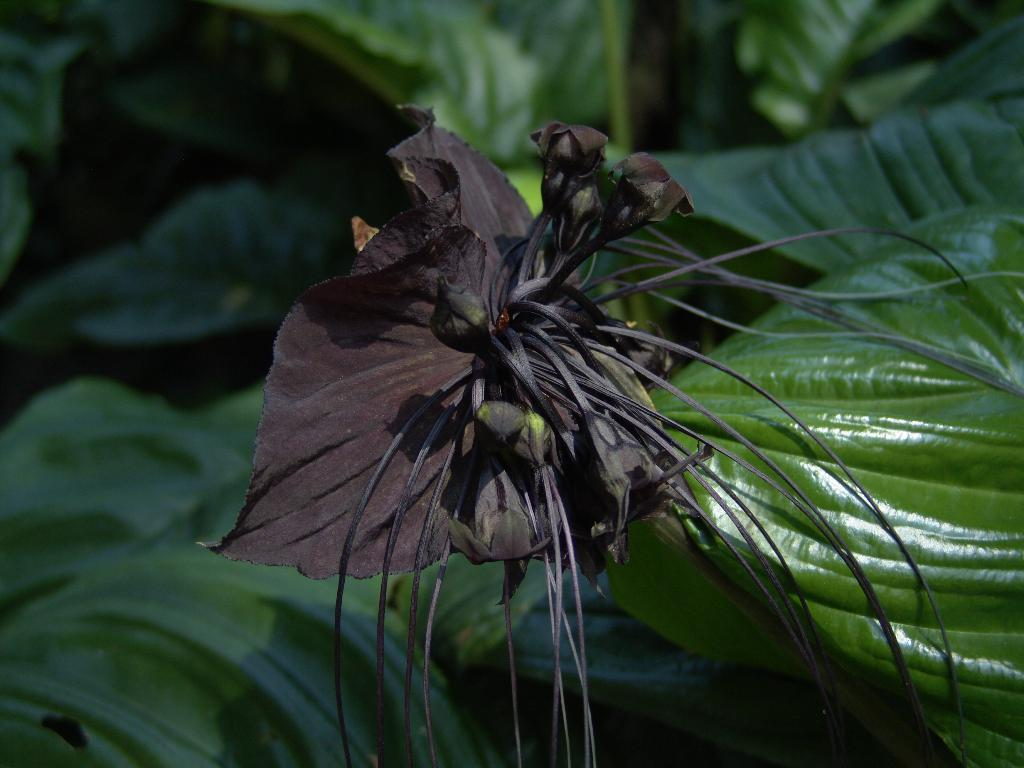What is the main subject of the image? There is a flower in the image. What can be seen in the background of the image? There are leaves in the background of the image. What are the hobbies of the flower in the image? The image does not provide information about the hobbies of the flower, as it is an inanimate object. 